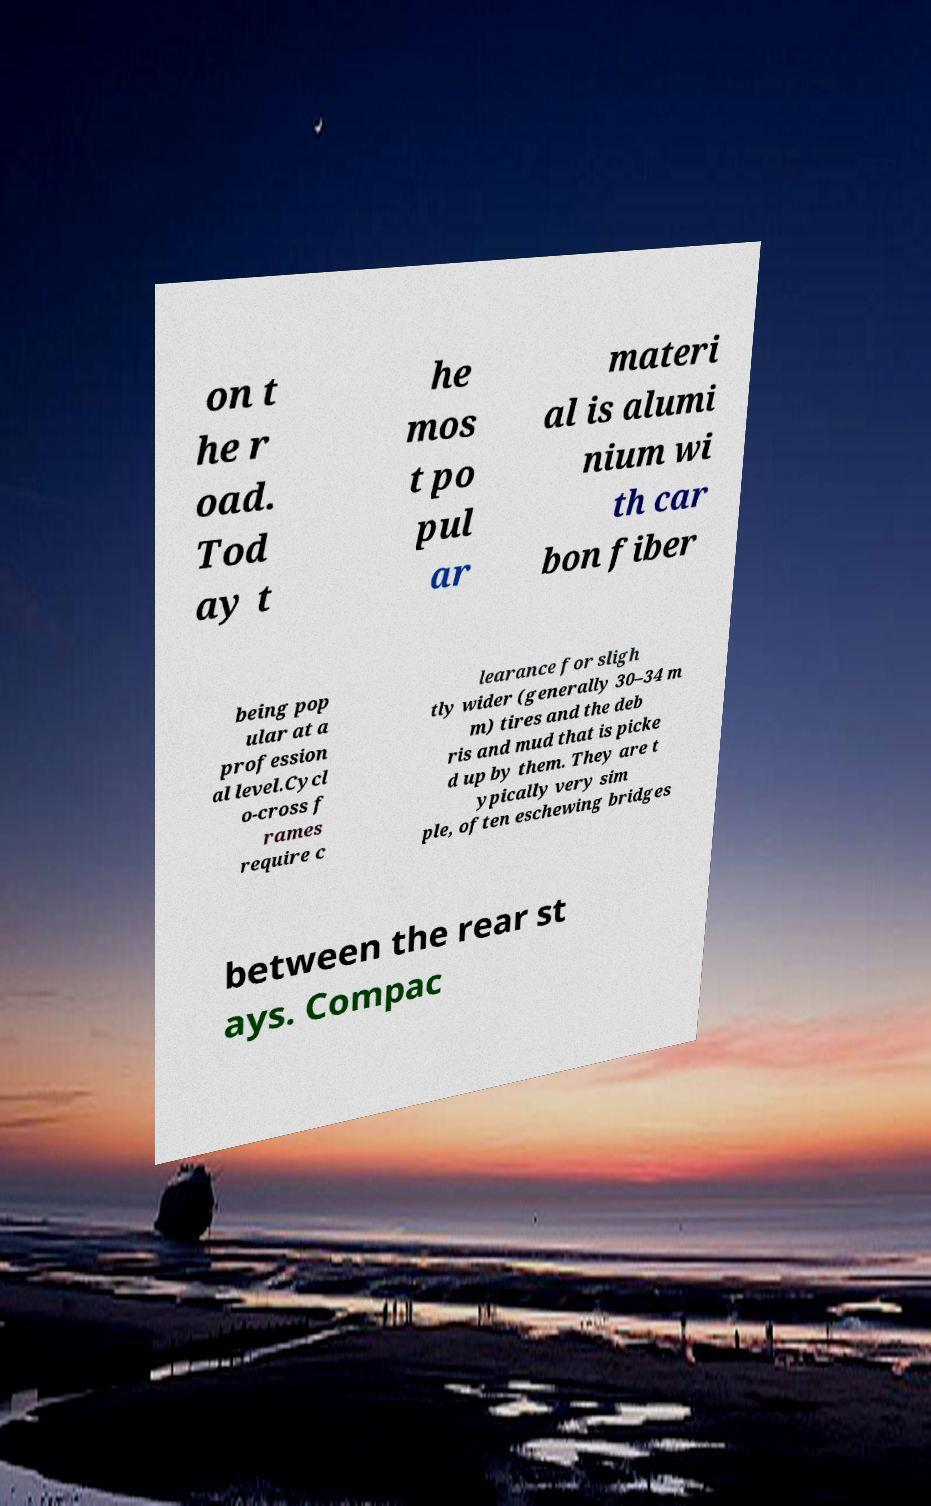Please read and relay the text visible in this image. What does it say? on t he r oad. Tod ay t he mos t po pul ar materi al is alumi nium wi th car bon fiber being pop ular at a profession al level.Cycl o-cross f rames require c learance for sligh tly wider (generally 30–34 m m) tires and the deb ris and mud that is picke d up by them. They are t ypically very sim ple, often eschewing bridges between the rear st ays. Compac 